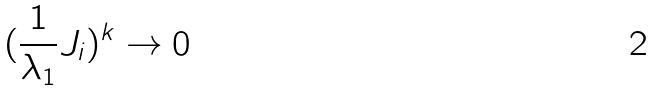<formula> <loc_0><loc_0><loc_500><loc_500>( \frac { 1 } { \lambda _ { 1 } } J _ { i } ) ^ { k } \rightarrow 0</formula> 